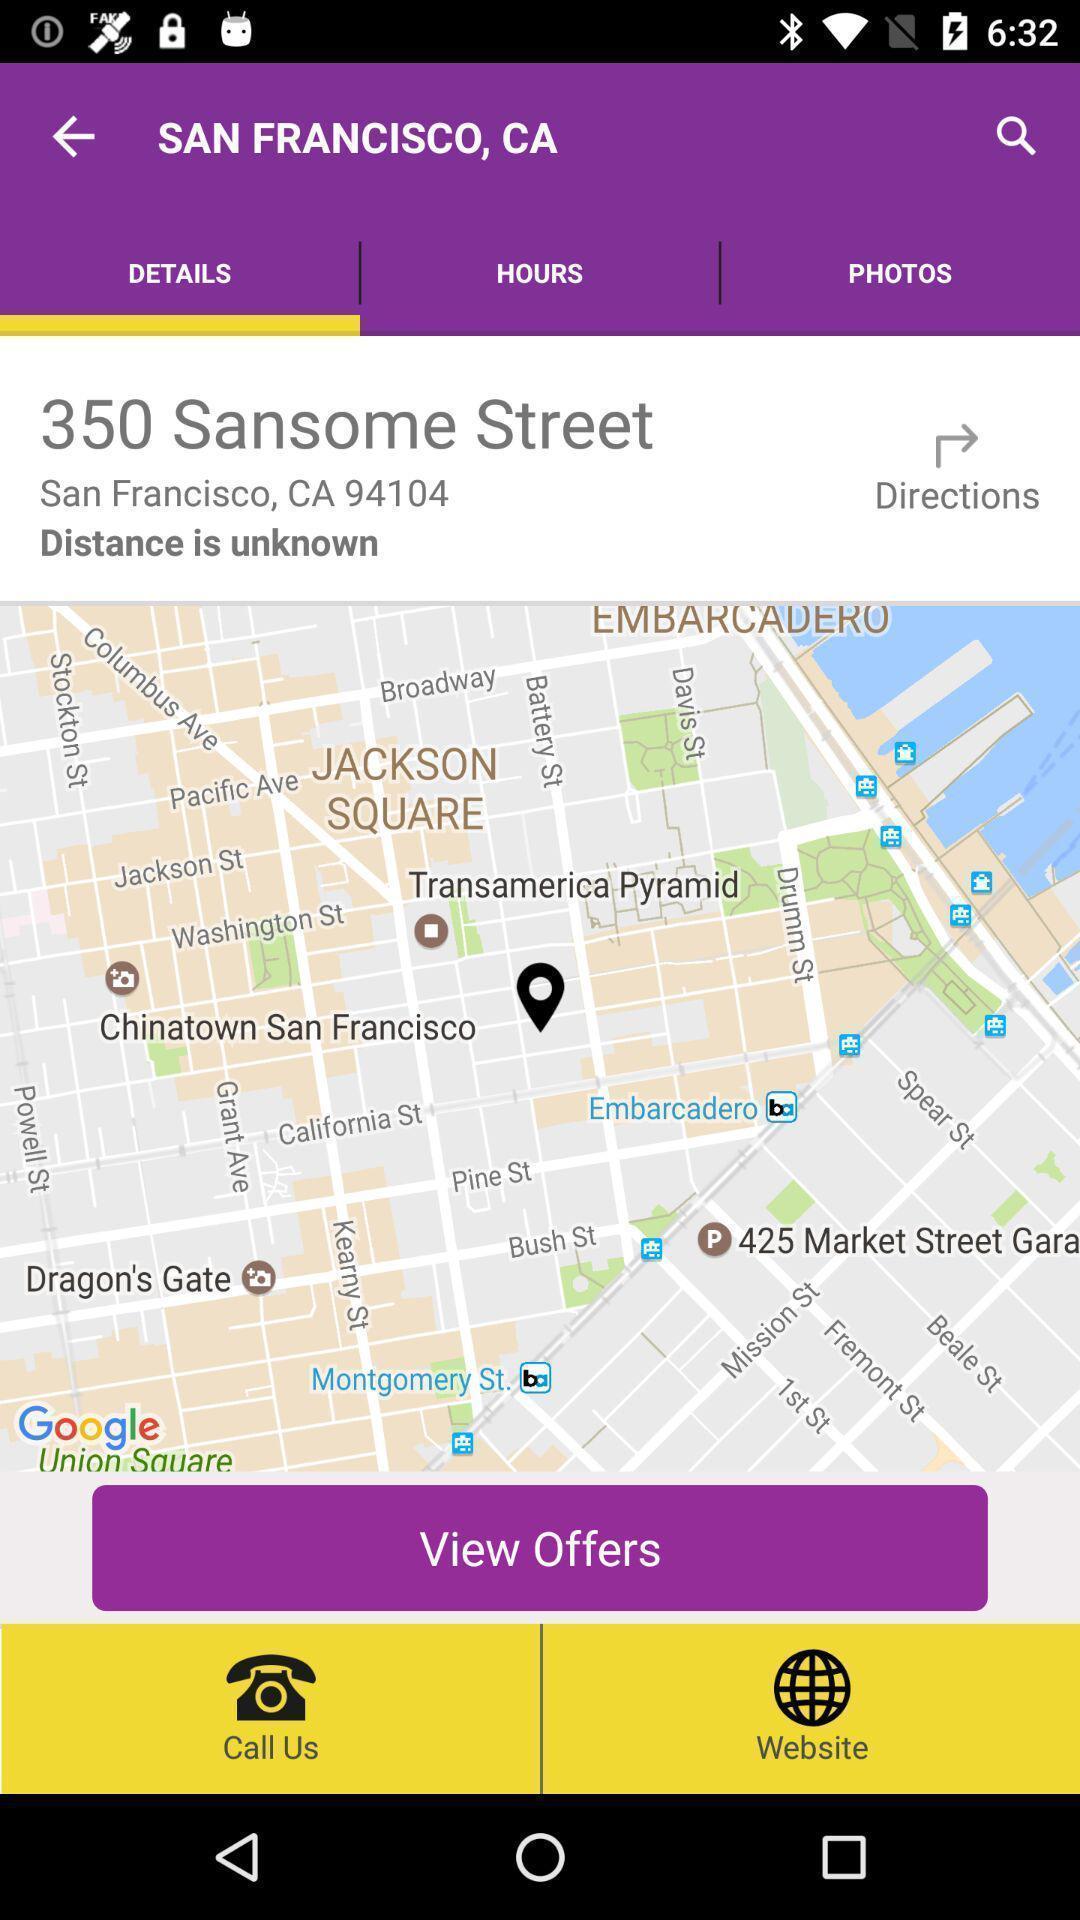Tell me what you see in this picture. Page that displaying a map. 